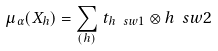Convert formula to latex. <formula><loc_0><loc_0><loc_500><loc_500>\mu _ { \alpha } ( X _ { h } ) = \sum _ { ( h ) } \, t _ { h \ s w 1 } \otimes h \ s w 2</formula> 